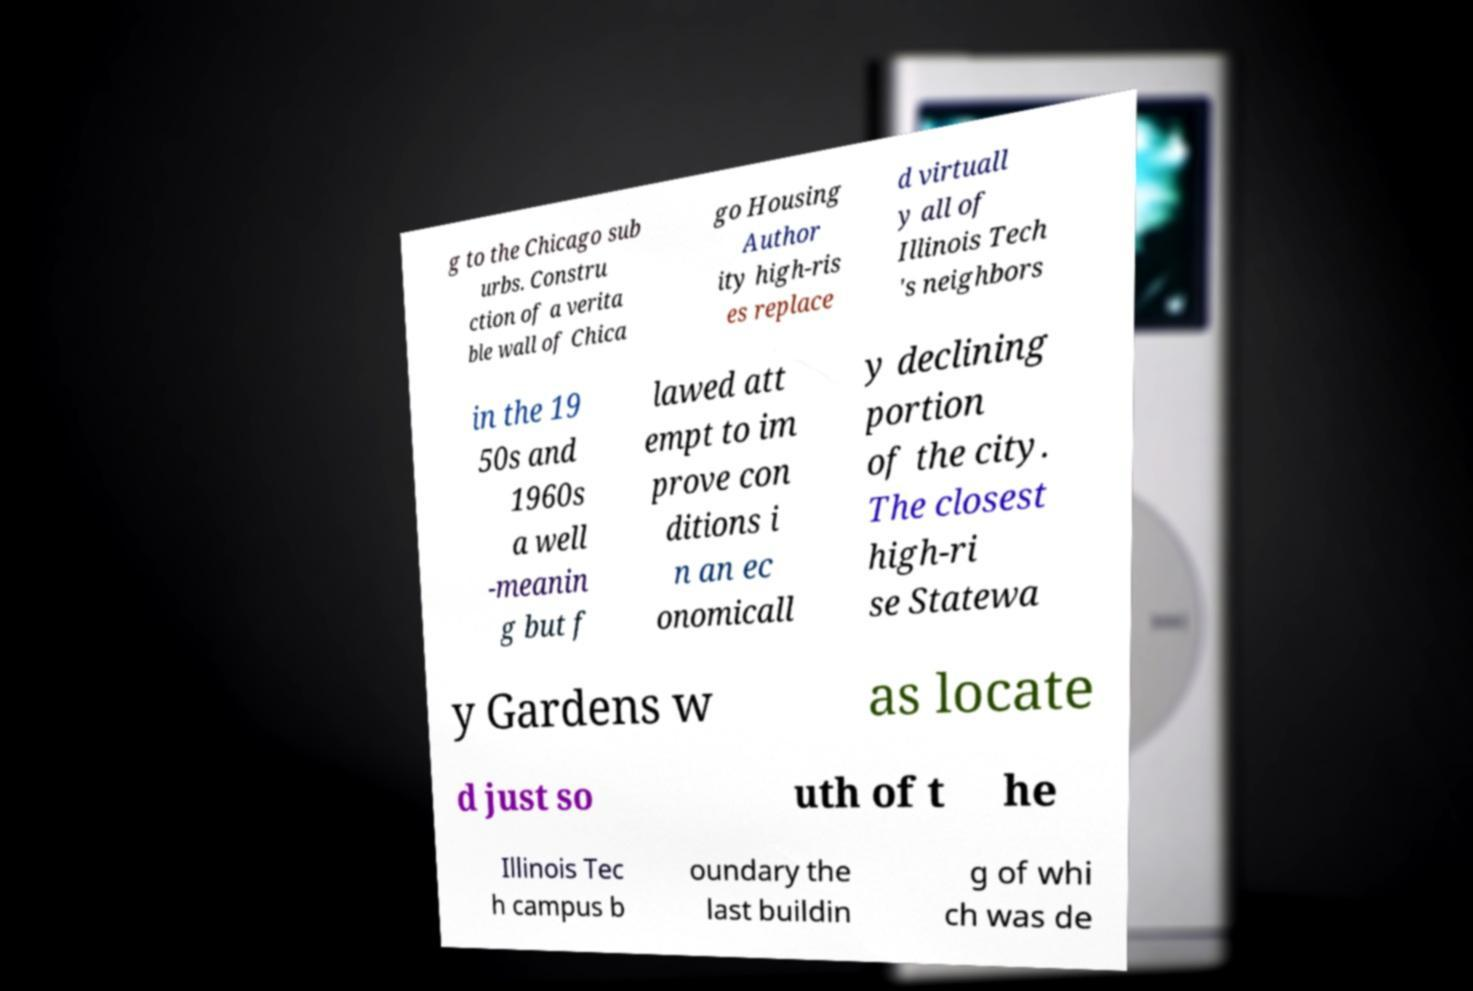For documentation purposes, I need the text within this image transcribed. Could you provide that? g to the Chicago sub urbs. Constru ction of a verita ble wall of Chica go Housing Author ity high-ris es replace d virtuall y all of Illinois Tech 's neighbors in the 19 50s and 1960s a well -meanin g but f lawed att empt to im prove con ditions i n an ec onomicall y declining portion of the city. The closest high-ri se Statewa y Gardens w as locate d just so uth of t he Illinois Tec h campus b oundary the last buildin g of whi ch was de 